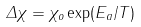Convert formula to latex. <formula><loc_0><loc_0><loc_500><loc_500>\Delta \chi = \chi _ { o } \exp ( E _ { a } / T )</formula> 